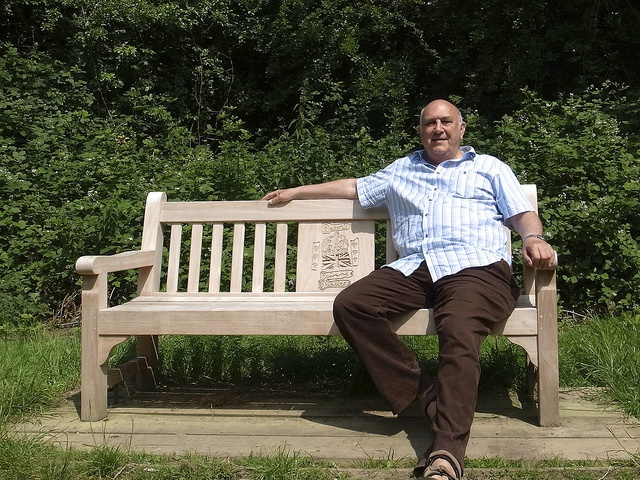Describe the objects in this image and their specific colors. I can see people in black, lavender, and gray tones, bench in black, lightgray, and tan tones, and clock in gray, darkgray, and black tones in this image. 